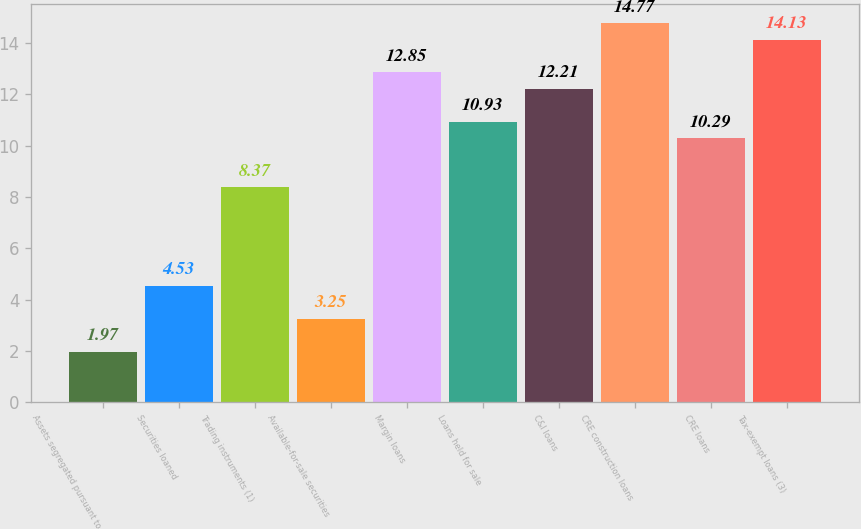Convert chart to OTSL. <chart><loc_0><loc_0><loc_500><loc_500><bar_chart><fcel>Assets segregated pursuant to<fcel>Securities loaned<fcel>Trading instruments (1)<fcel>Available-for-sale securities<fcel>Margin loans<fcel>Loans held for sale<fcel>C&I loans<fcel>CRE construction loans<fcel>CRE loans<fcel>Tax-exempt loans (3)<nl><fcel>1.97<fcel>4.53<fcel>8.37<fcel>3.25<fcel>12.85<fcel>10.93<fcel>12.21<fcel>14.77<fcel>10.29<fcel>14.13<nl></chart> 